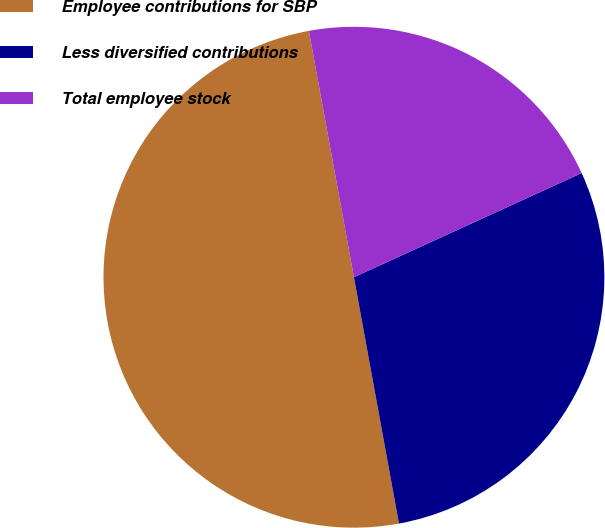Convert chart to OTSL. <chart><loc_0><loc_0><loc_500><loc_500><pie_chart><fcel>Employee contributions for SBP<fcel>Less diversified contributions<fcel>Total employee stock<nl><fcel>50.0%<fcel>28.95%<fcel>21.05%<nl></chart> 